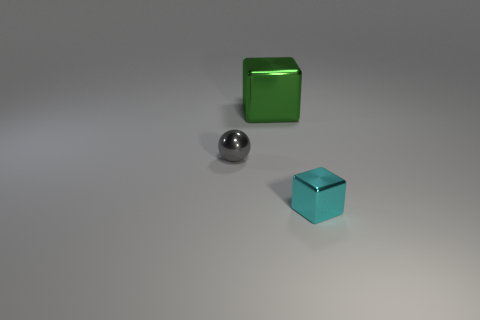Add 1 green metal cubes. How many objects exist? 4 Subtract all blocks. How many objects are left? 1 Subtract 0 blue cubes. How many objects are left? 3 Subtract all tiny cyan cubes. Subtract all small red rubber cylinders. How many objects are left? 2 Add 2 tiny blocks. How many tiny blocks are left? 3 Add 3 green blocks. How many green blocks exist? 4 